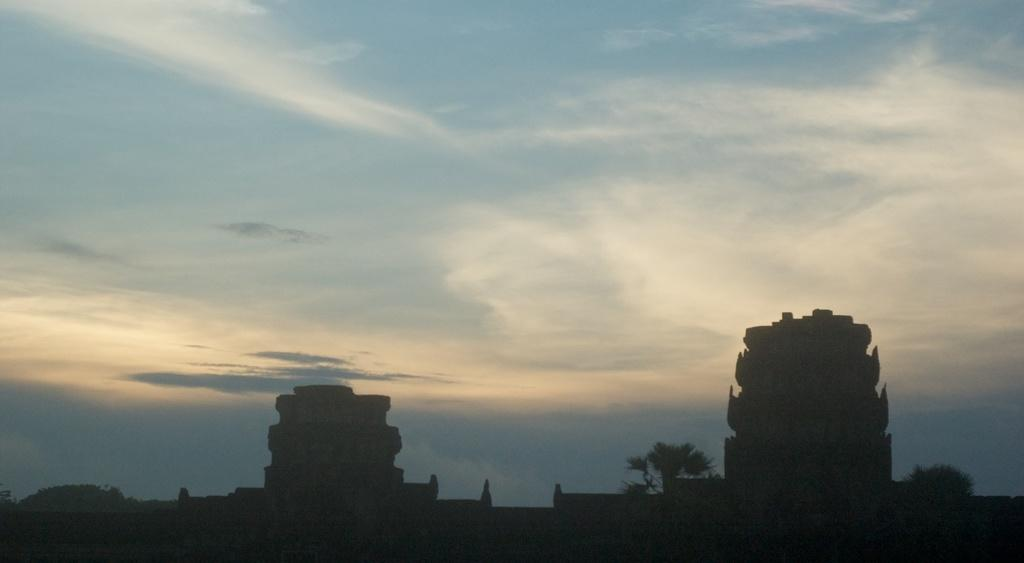What type of structures can be seen in the image? There are buildings in the image. What other natural elements are present in the image? There are trees in the image. What can be seen in the sky in the image? There are clouds visible in the sky. What type of riddle is being solved by the trees in the image? There is no riddle being solved by the trees in the image; they are simply trees. What is the spark used for in the image? There is no spark present in the image. 